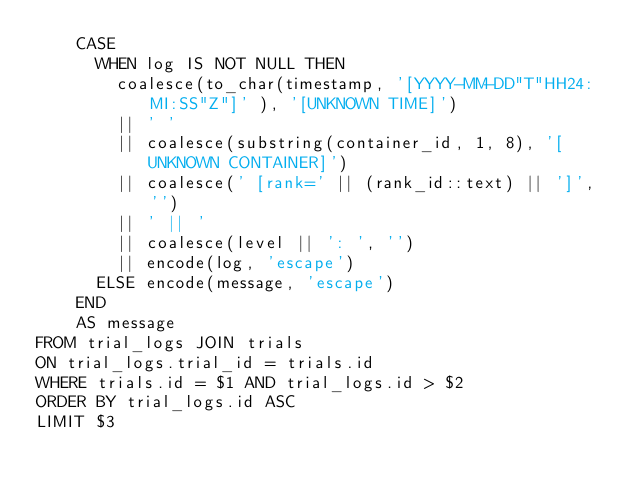Convert code to text. <code><loc_0><loc_0><loc_500><loc_500><_SQL_>    CASE
      WHEN log IS NOT NULL THEN
        coalesce(to_char(timestamp, '[YYYY-MM-DD"T"HH24:MI:SS"Z"]' ), '[UNKNOWN TIME]')
        || ' '
        || coalesce(substring(container_id, 1, 8), '[UNKNOWN CONTAINER]')
        || coalesce(' [rank=' || (rank_id::text) || ']', '')
        || ' || '
        || coalesce(level || ': ', '')
        || encode(log, 'escape')
      ELSE encode(message, 'escape')
    END
    AS message
FROM trial_logs JOIN trials
ON trial_logs.trial_id = trials.id
WHERE trials.id = $1 AND trial_logs.id > $2
ORDER BY trial_logs.id ASC
LIMIT $3
</code> 